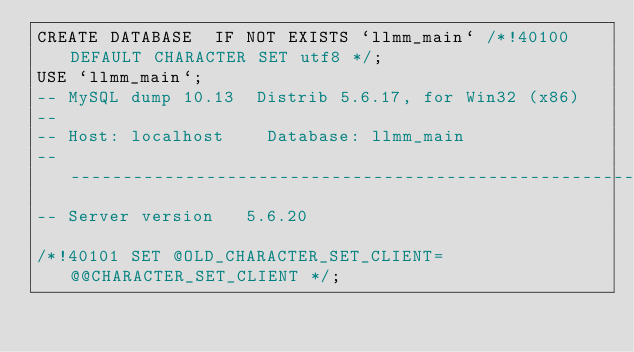Convert code to text. <code><loc_0><loc_0><loc_500><loc_500><_SQL_>CREATE DATABASE  IF NOT EXISTS `llmm_main` /*!40100 DEFAULT CHARACTER SET utf8 */;
USE `llmm_main`;
-- MySQL dump 10.13  Distrib 5.6.17, for Win32 (x86)
--
-- Host: localhost    Database: llmm_main
-- ------------------------------------------------------
-- Server version	5.6.20

/*!40101 SET @OLD_CHARACTER_SET_CLIENT=@@CHARACTER_SET_CLIENT */;</code> 